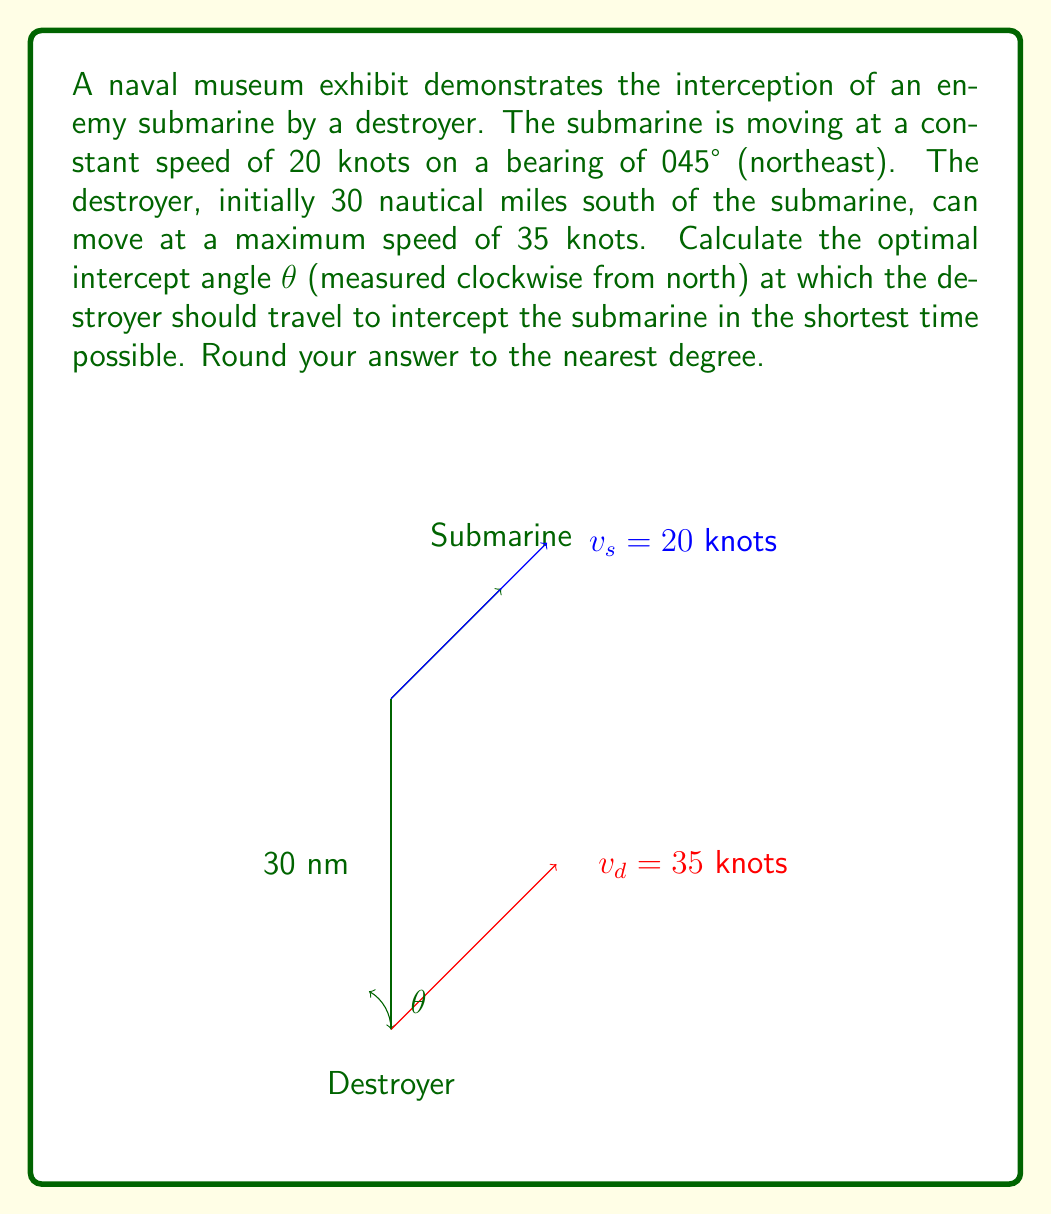Help me with this question. To solve this problem, we'll use the principle of relative motion and the law of sines. Let's break it down step by step:

1) First, we need to understand that the optimal intercept angle is the one that makes the relative velocity vector of the destroyer (with respect to the submarine) point directly at the submarine.

2) Let's define our variables:
   $v_s = 20$ knots (submarine speed)
   $v_d = 35$ knots (destroyer speed)
   $θ$ = intercept angle (what we're solving for)
   $φ = 45°$ (submarine's bearing)

3) We can set up a vector triangle where:
   - One side is the submarine's velocity vector
   - One side is the destroyer's velocity vector
   - The third side is the relative velocity vector

4) In this triangle, we know two sides (the speeds) and one angle (the difference between the submarine's bearing and the destroyer's course). We can use the law of sines:

   $$\frac{\sin(180° - θ)}{v_s} = \frac{\sin(θ - φ)}{v_d}$$

5) Simplify using the sine of supplementary angle identity:

   $$\frac{\sin θ}{20} = \frac{\sin(θ - 45°)}{35}$$

6) Expand the right side:

   $$\frac{\sin θ}{20} = \frac{\sin θ \cos 45° - \cos θ \sin 45°}{35}$$

7) Substitute $\cos 45° = \sin 45° = \frac{1}{\sqrt{2}}$:

   $$\frac{\sin θ}{20} = \frac{\sin θ \frac{1}{\sqrt{2}} - \cos θ \frac{1}{\sqrt{2}}}{35}$$

8) Multiply both sides by 35:

   $$\frac{35 \sin θ}{20} = \frac{\sin θ - \cos θ}{\sqrt{2}}$$

9) Square both sides to eliminate the square root:

   $$(\frac{35 \sin θ}{20})^2 = (\frac{\sin θ - \cos θ}{\sqrt{2}})^2$$

10) Expand and simplify:

    $$\frac{1225 \sin^2 θ}{400} = \frac{\sin^2 θ - 2\sin θ \cos θ + \cos^2 θ}{2}$$

11) Multiply both sides by 800:

    $$2450 \sin^2 θ = 400(\sin^2 θ - 2\sin θ \cos θ + \cos^2 θ)$$

12) Expand:

    $$2450 \sin^2 θ = 400\sin^2 θ - 800\sin θ \cos θ + 400\cos^2 θ$$

13) Rearrange:

    $$2050 \sin^2 θ - 800\sin θ \cos θ - 400\cos^2 θ = 0$$

14) Divide by $\cos^2 θ$:

    $$2050 \tan^2 θ - 800\tan θ - 400 = 0$$

15) This is a quadratic in $\tan θ$. Solve using the quadratic formula:

    $$\tan θ = \frac{800 \pm \sqrt{640000 + 3280000}}{4100} = \frac{800 \pm 2400}{4100}$$

16) We want the positive solution:

    $$\tan θ = \frac{3200}{4100} \approx 0.7805$$

17) Take the inverse tangent and convert to degrees:

    $$θ = \tan^{-1}(0.7805) \approx 37.97°$$

18) Rounding to the nearest degree:

    $$θ ≈ 38°$$
Answer: The optimal intercept angle is approximately 38°. 